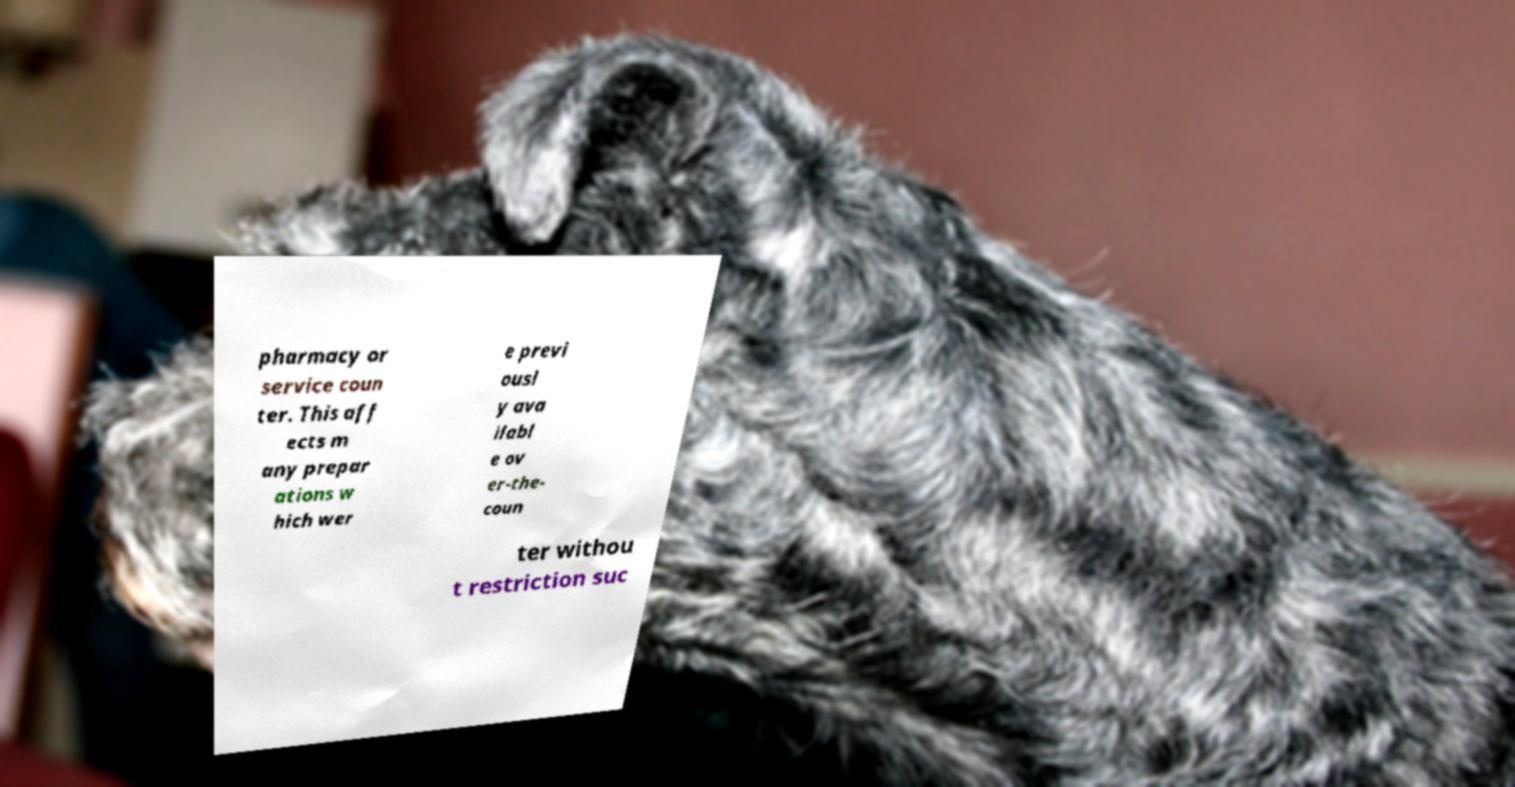Please read and relay the text visible in this image. What does it say? pharmacy or service coun ter. This aff ects m any prepar ations w hich wer e previ ousl y ava ilabl e ov er-the- coun ter withou t restriction suc 